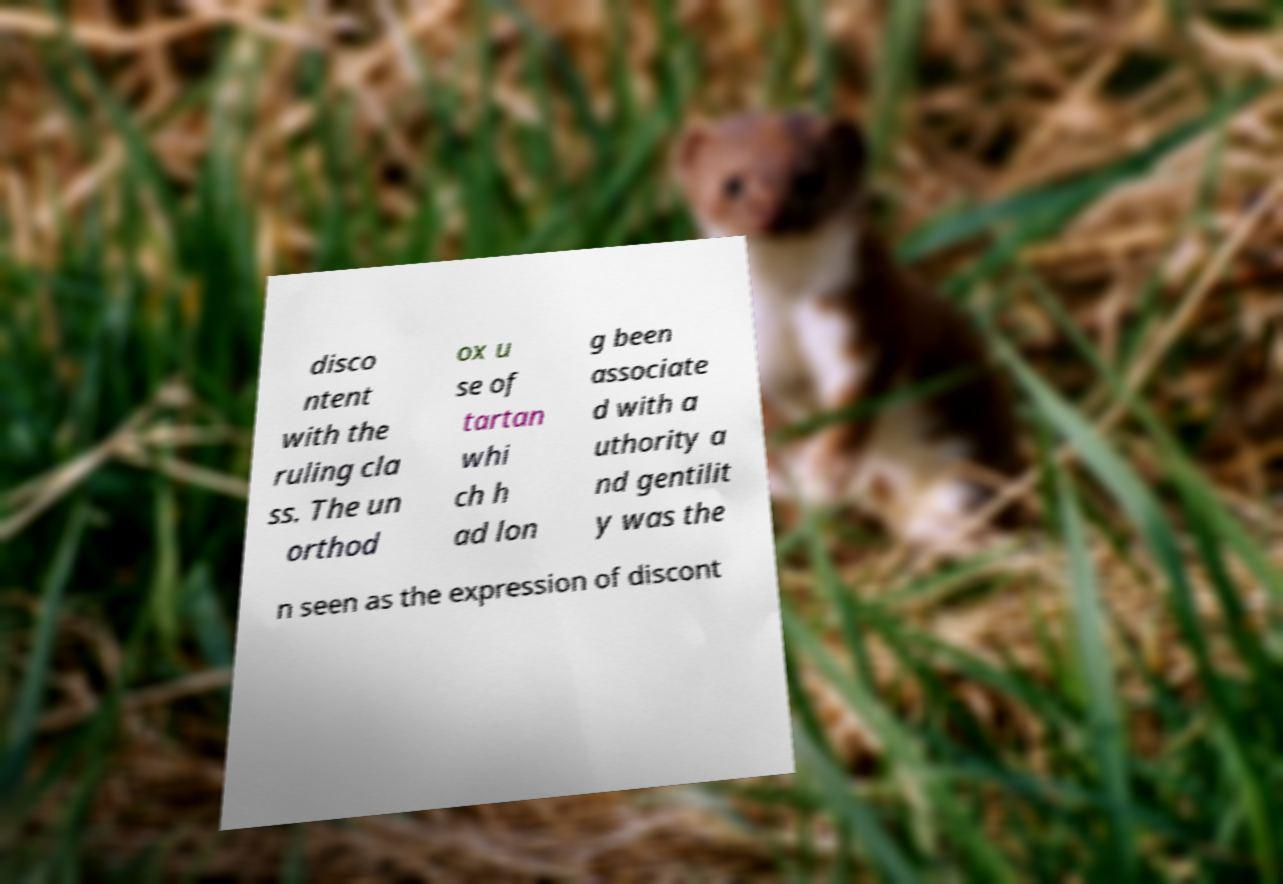Can you accurately transcribe the text from the provided image for me? disco ntent with the ruling cla ss. The un orthod ox u se of tartan whi ch h ad lon g been associate d with a uthority a nd gentilit y was the n seen as the expression of discont 